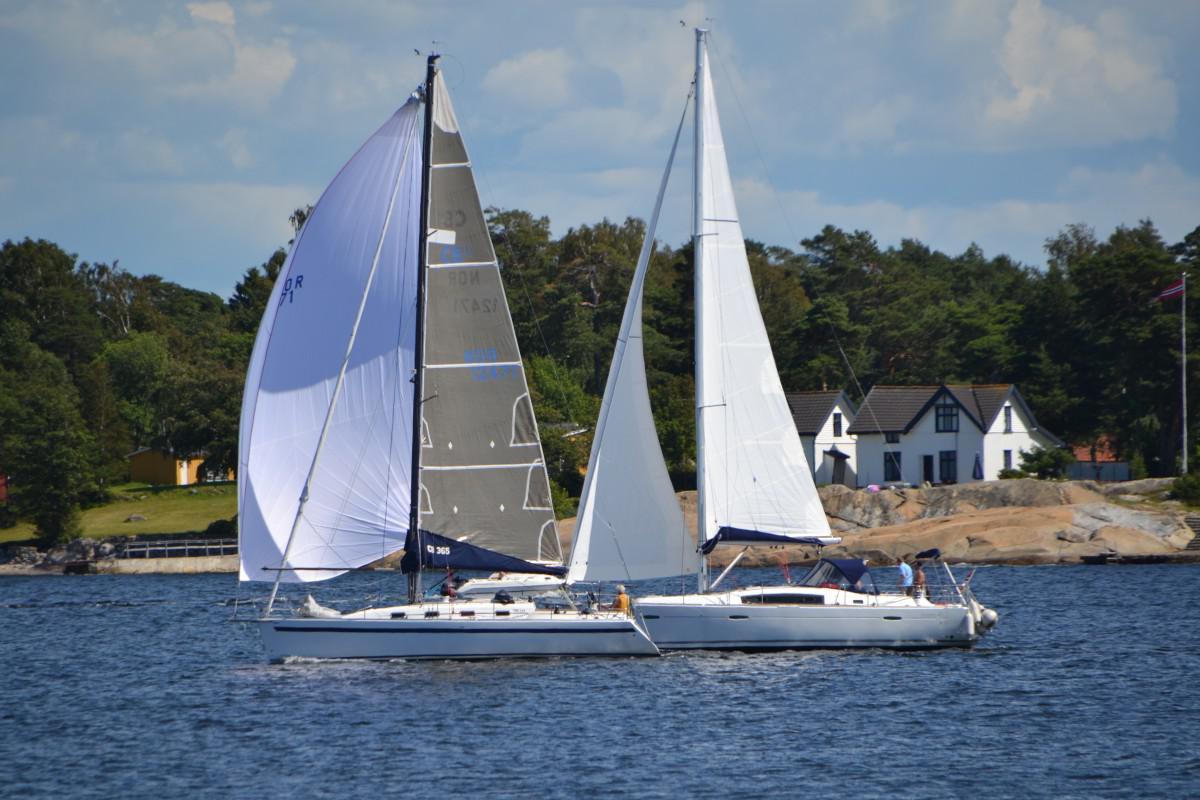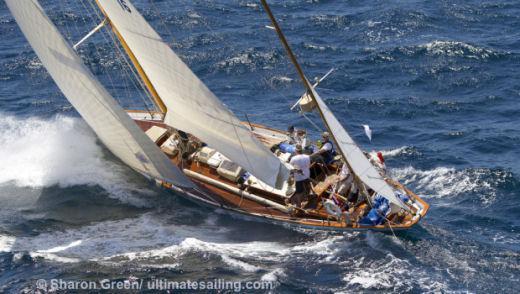The first image is the image on the left, the second image is the image on the right. For the images shown, is this caption "At least one of the ship has at least one sail that is not up." true? Answer yes or no. No. 